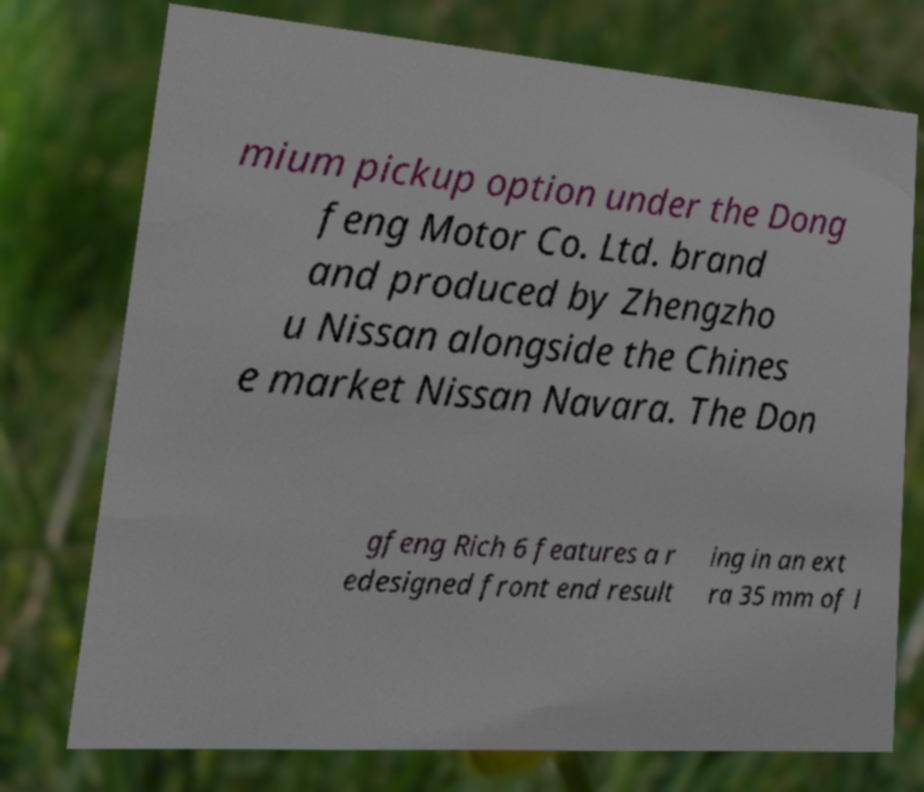Please read and relay the text visible in this image. What does it say? mium pickup option under the Dong feng Motor Co. Ltd. brand and produced by Zhengzho u Nissan alongside the Chines e market Nissan Navara. The Don gfeng Rich 6 features a r edesigned front end result ing in an ext ra 35 mm of l 